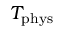Convert formula to latex. <formula><loc_0><loc_0><loc_500><loc_500>T _ { p h y s }</formula> 